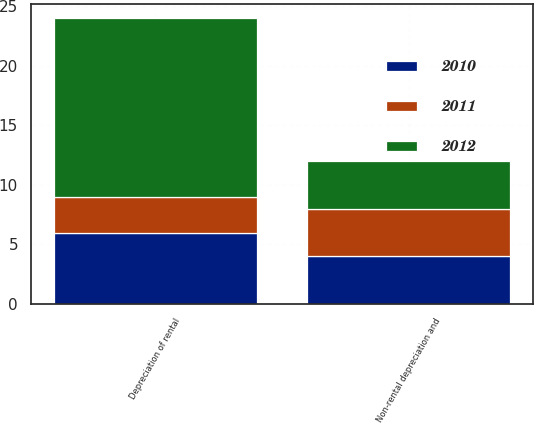Convert chart. <chart><loc_0><loc_0><loc_500><loc_500><stacked_bar_chart><ecel><fcel>Depreciation of rental<fcel>Non-rental depreciation and<nl><fcel>2012<fcel>15<fcel>4<nl><fcel>2011<fcel>3<fcel>4<nl><fcel>2010<fcel>6<fcel>4<nl></chart> 